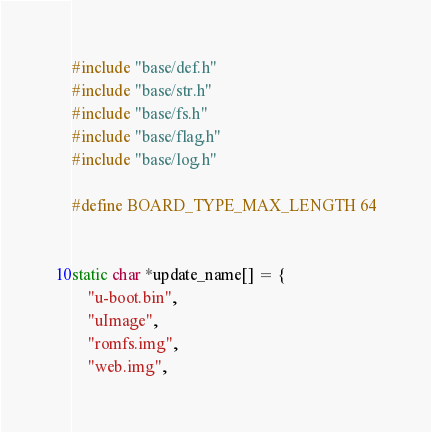Convert code to text. <code><loc_0><loc_0><loc_500><loc_500><_C++_>#include "base/def.h"
#include "base/str.h"
#include "base/fs.h"
#include "base/flag.h"
#include "base/log.h"

#define BOARD_TYPE_MAX_LENGTH 64


static char *update_name[] = {
    "u-boot.bin",
    "uImage",
    "romfs.img",
    "web.img",</code> 